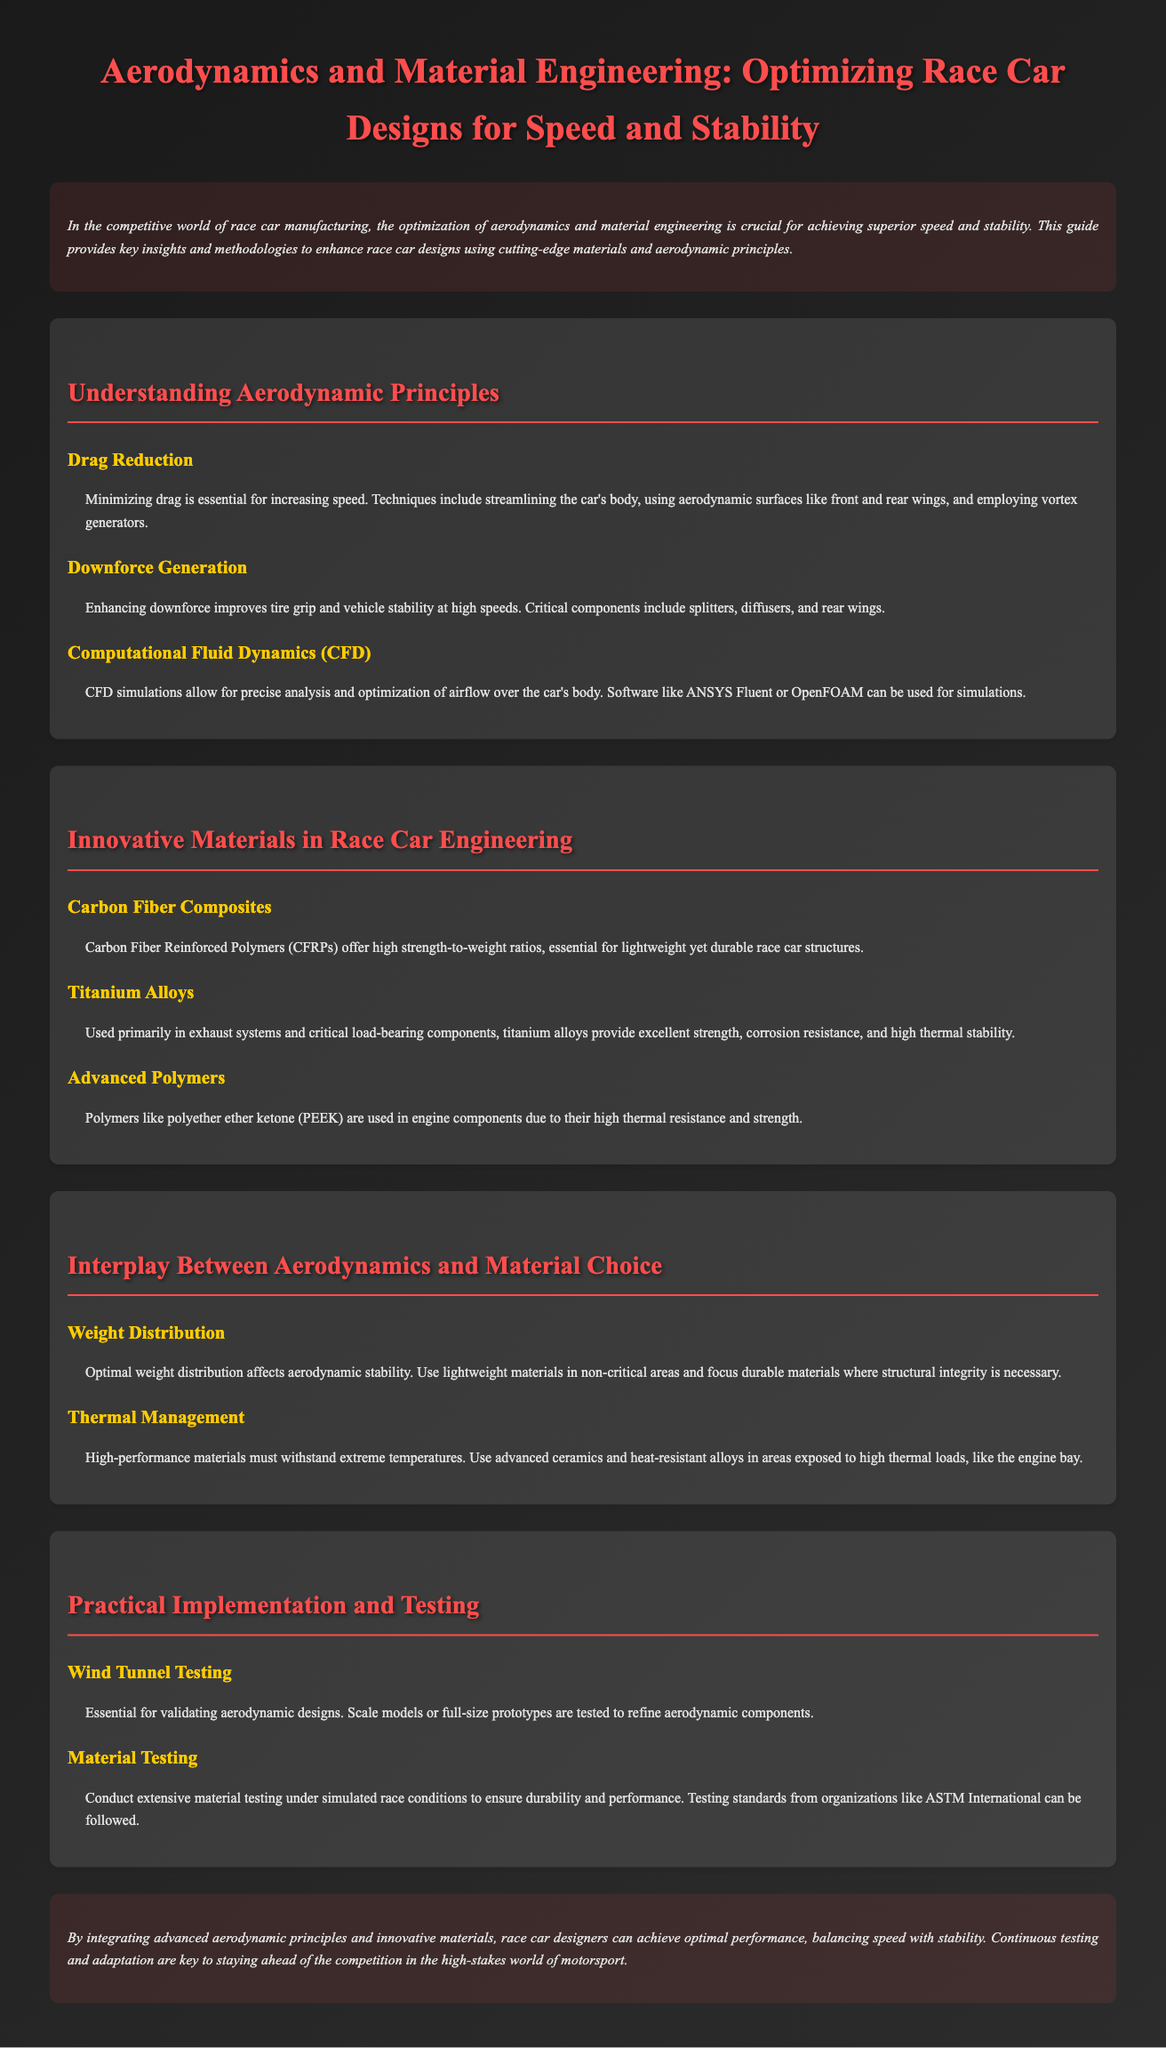What is the primary focus of the guide? The guide focuses on optimizing race car designs through aerodynamics and material engineering to achieve speed and stability.
Answer: Optimizing race car designs What material is highlighted for its high strength-to-weight ratio? The document mentions Carbon Fiber Reinforced Polymers as having high strength-to-weight ratios, which is essential for race car structures.
Answer: Carbon Fiber Composites What is a technique to reduce drag? The guide lists streamlining the car's body as a technique for minimizing drag to increase speed.
Answer: Streamlining the car's body Which computational tool is mentioned for aerodynamic analysis? Computational Fluid Dynamics using software like ANSYS Fluent or OpenFOAM is mentioned for precise airflow analysis over the car's body.
Answer: Computational Fluid Dynamics (CFD) What component helps generate downforce? The guide notes rear wings as critical components for enhancing downforce and improving vehicle stability at high speeds.
Answer: Rear wings How does weight distribution affect aerodynamics? The document states that optimal weight distribution affects aerodynamic stability by using lightweight materials in non-critical areas.
Answer: Aerodynamic stability Which testing method is essential for validating aerodynamic designs? Wind tunnel testing is essential for validating aerodynamic designs according to the document.
Answer: Wind Tunnel Testing What material is preferred for parts exposed to high thermal loads? Advanced ceramics and heat-resistant alloys are recommended for areas exposed to high thermal loads.
Answer: Advanced ceramics and heat-resistant alloys 